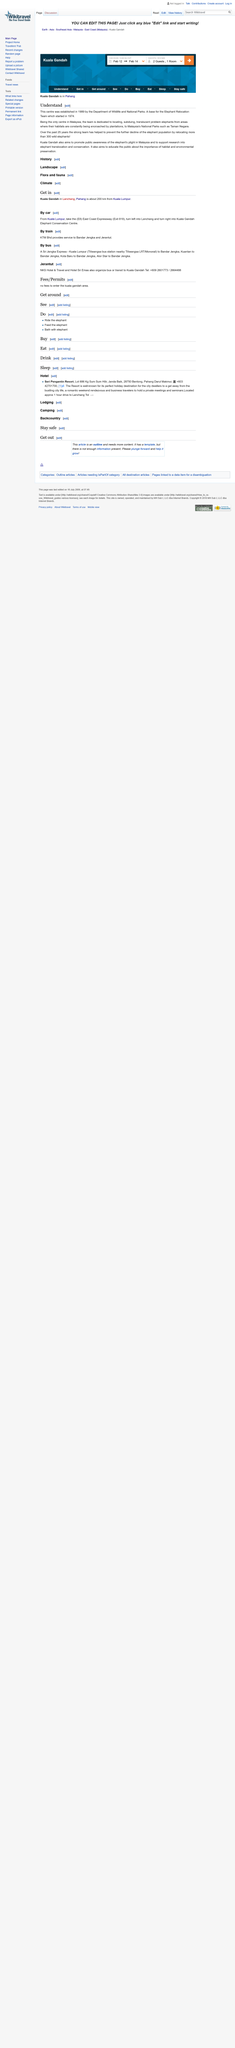Give some essential details in this illustration. The Department of Wildlife and National Parks established the centre. The Elephant Translocation Centre was established in 1989 and has since relocated more than 300 elephants. The Elephant Relocation Team began its operations in 1974. 